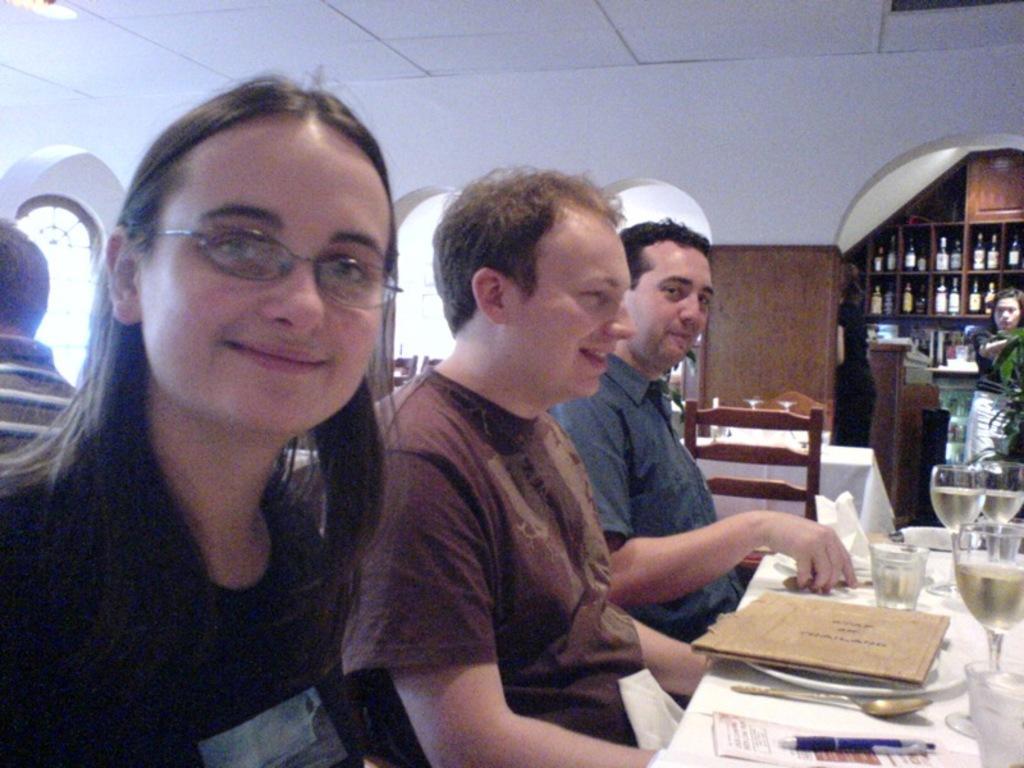Describe this image in one or two sentences. This picture shows few people seated and we see classes and menu card and paper with pen and couple of plates on the table and we see a spoon and we see a woman standing and few bottles in the cupboard and few chairs and tables and a woman seated on the back. 